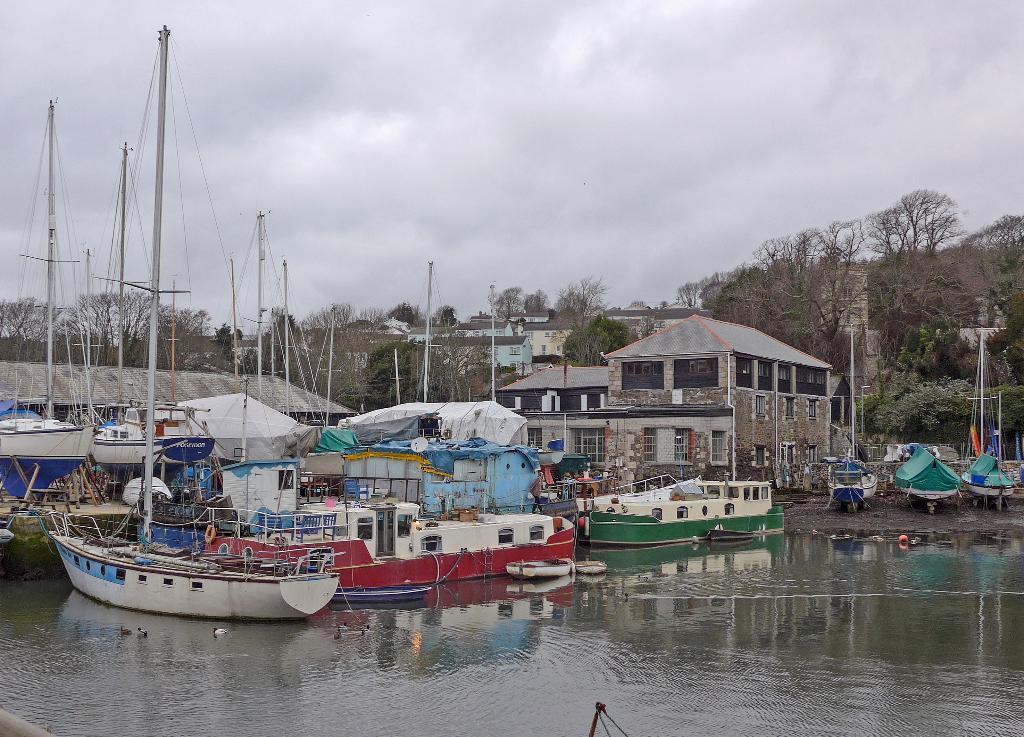How would you summarize this image in a sentence or two? In this image, I can see few boats on the water. I think these are the ducks in the water. I can see the buildings with windows. In the background, these are the trees. This is the sky. 